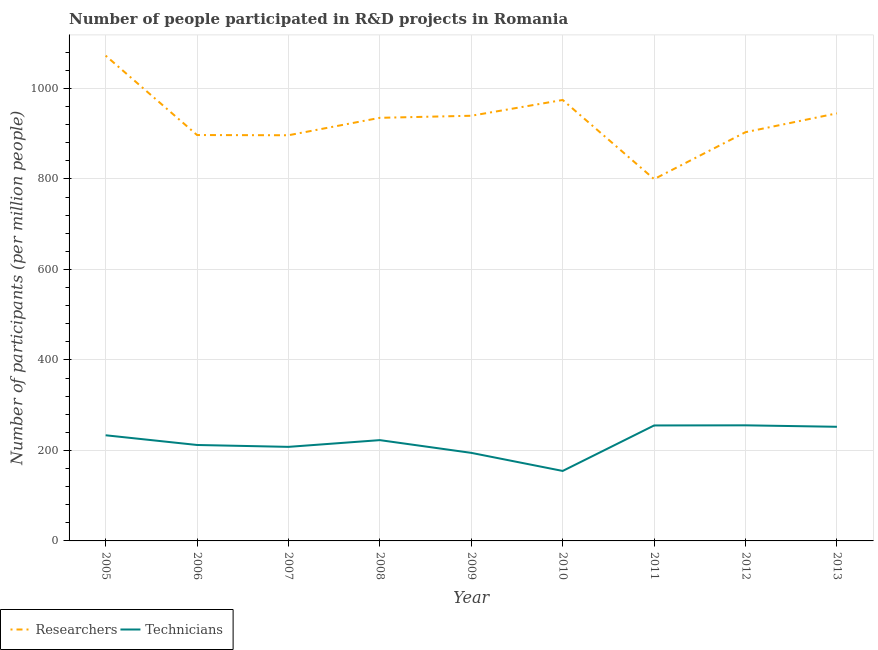How many different coloured lines are there?
Your answer should be very brief. 2. What is the number of technicians in 2008?
Provide a succinct answer. 222.74. Across all years, what is the maximum number of technicians?
Ensure brevity in your answer.  255.45. Across all years, what is the minimum number of technicians?
Offer a terse response. 154.64. In which year was the number of researchers maximum?
Give a very brief answer. 2005. What is the total number of researchers in the graph?
Make the answer very short. 8362.66. What is the difference between the number of researchers in 2012 and that in 2013?
Your response must be concise. -41.64. What is the difference between the number of technicians in 2007 and the number of researchers in 2006?
Make the answer very short. -689.1. What is the average number of technicians per year?
Make the answer very short. 220.91. In the year 2012, what is the difference between the number of technicians and number of researchers?
Provide a short and direct response. -647.83. In how many years, is the number of technicians greater than 160?
Ensure brevity in your answer.  8. What is the ratio of the number of researchers in 2006 to that in 2007?
Provide a succinct answer. 1. Is the number of technicians in 2009 less than that in 2010?
Your answer should be compact. No. What is the difference between the highest and the second highest number of technicians?
Provide a short and direct response. 0.28. What is the difference between the highest and the lowest number of technicians?
Offer a very short reply. 100.81. Does the number of researchers monotonically increase over the years?
Give a very brief answer. No. Is the number of technicians strictly greater than the number of researchers over the years?
Provide a short and direct response. No. Is the number of technicians strictly less than the number of researchers over the years?
Make the answer very short. Yes. How many lines are there?
Ensure brevity in your answer.  2. How many years are there in the graph?
Make the answer very short. 9. Does the graph contain any zero values?
Your answer should be very brief. No. Where does the legend appear in the graph?
Your response must be concise. Bottom left. How many legend labels are there?
Offer a very short reply. 2. What is the title of the graph?
Ensure brevity in your answer.  Number of people participated in R&D projects in Romania. What is the label or title of the X-axis?
Make the answer very short. Year. What is the label or title of the Y-axis?
Make the answer very short. Number of participants (per million people). What is the Number of participants (per million people) of Researchers in 2005?
Give a very brief answer. 1072.42. What is the Number of participants (per million people) of Technicians in 2005?
Keep it short and to the point. 233.47. What is the Number of participants (per million people) of Researchers in 2006?
Make the answer very short. 896.96. What is the Number of participants (per million people) of Technicians in 2006?
Provide a succinct answer. 212.02. What is the Number of participants (per million people) of Researchers in 2007?
Give a very brief answer. 896.49. What is the Number of participants (per million people) of Technicians in 2007?
Ensure brevity in your answer.  207.87. What is the Number of participants (per million people) of Researchers in 2008?
Provide a succinct answer. 935.03. What is the Number of participants (per million people) in Technicians in 2008?
Ensure brevity in your answer.  222.74. What is the Number of participants (per million people) of Researchers in 2009?
Your response must be concise. 939.58. What is the Number of participants (per million people) in Technicians in 2009?
Provide a short and direct response. 194.59. What is the Number of participants (per million people) in Researchers in 2010?
Give a very brief answer. 974.44. What is the Number of participants (per million people) in Technicians in 2010?
Provide a short and direct response. 154.64. What is the Number of participants (per million people) of Researchers in 2011?
Ensure brevity in your answer.  799.54. What is the Number of participants (per million people) of Technicians in 2011?
Your answer should be very brief. 255.18. What is the Number of participants (per million people) in Researchers in 2012?
Give a very brief answer. 903.29. What is the Number of participants (per million people) in Technicians in 2012?
Make the answer very short. 255.45. What is the Number of participants (per million people) of Researchers in 2013?
Offer a terse response. 944.93. What is the Number of participants (per million people) in Technicians in 2013?
Offer a terse response. 252.25. Across all years, what is the maximum Number of participants (per million people) of Researchers?
Your answer should be very brief. 1072.42. Across all years, what is the maximum Number of participants (per million people) of Technicians?
Provide a succinct answer. 255.45. Across all years, what is the minimum Number of participants (per million people) of Researchers?
Make the answer very short. 799.54. Across all years, what is the minimum Number of participants (per million people) of Technicians?
Your response must be concise. 154.64. What is the total Number of participants (per million people) in Researchers in the graph?
Provide a short and direct response. 8362.66. What is the total Number of participants (per million people) of Technicians in the graph?
Provide a succinct answer. 1988.19. What is the difference between the Number of participants (per million people) in Researchers in 2005 and that in 2006?
Offer a terse response. 175.46. What is the difference between the Number of participants (per million people) in Technicians in 2005 and that in 2006?
Ensure brevity in your answer.  21.45. What is the difference between the Number of participants (per million people) in Researchers in 2005 and that in 2007?
Make the answer very short. 175.94. What is the difference between the Number of participants (per million people) in Technicians in 2005 and that in 2007?
Offer a very short reply. 25.6. What is the difference between the Number of participants (per million people) in Researchers in 2005 and that in 2008?
Provide a short and direct response. 137.4. What is the difference between the Number of participants (per million people) in Technicians in 2005 and that in 2008?
Your answer should be compact. 10.73. What is the difference between the Number of participants (per million people) of Researchers in 2005 and that in 2009?
Give a very brief answer. 132.84. What is the difference between the Number of participants (per million people) of Technicians in 2005 and that in 2009?
Your answer should be compact. 38.88. What is the difference between the Number of participants (per million people) of Researchers in 2005 and that in 2010?
Offer a very short reply. 97.98. What is the difference between the Number of participants (per million people) of Technicians in 2005 and that in 2010?
Your response must be concise. 78.83. What is the difference between the Number of participants (per million people) in Researchers in 2005 and that in 2011?
Keep it short and to the point. 272.89. What is the difference between the Number of participants (per million people) of Technicians in 2005 and that in 2011?
Your answer should be compact. -21.71. What is the difference between the Number of participants (per million people) in Researchers in 2005 and that in 2012?
Ensure brevity in your answer.  169.14. What is the difference between the Number of participants (per million people) in Technicians in 2005 and that in 2012?
Your answer should be very brief. -21.98. What is the difference between the Number of participants (per million people) of Researchers in 2005 and that in 2013?
Ensure brevity in your answer.  127.5. What is the difference between the Number of participants (per million people) in Technicians in 2005 and that in 2013?
Make the answer very short. -18.78. What is the difference between the Number of participants (per million people) in Researchers in 2006 and that in 2007?
Give a very brief answer. 0.48. What is the difference between the Number of participants (per million people) of Technicians in 2006 and that in 2007?
Keep it short and to the point. 4.15. What is the difference between the Number of participants (per million people) in Researchers in 2006 and that in 2008?
Provide a short and direct response. -38.06. What is the difference between the Number of participants (per million people) of Technicians in 2006 and that in 2008?
Ensure brevity in your answer.  -10.72. What is the difference between the Number of participants (per million people) of Researchers in 2006 and that in 2009?
Give a very brief answer. -42.61. What is the difference between the Number of participants (per million people) of Technicians in 2006 and that in 2009?
Provide a succinct answer. 17.43. What is the difference between the Number of participants (per million people) of Researchers in 2006 and that in 2010?
Provide a short and direct response. -77.48. What is the difference between the Number of participants (per million people) of Technicians in 2006 and that in 2010?
Your answer should be compact. 57.38. What is the difference between the Number of participants (per million people) in Researchers in 2006 and that in 2011?
Your answer should be compact. 97.43. What is the difference between the Number of participants (per million people) in Technicians in 2006 and that in 2011?
Your answer should be compact. -43.16. What is the difference between the Number of participants (per million people) in Researchers in 2006 and that in 2012?
Provide a succinct answer. -6.32. What is the difference between the Number of participants (per million people) of Technicians in 2006 and that in 2012?
Keep it short and to the point. -43.44. What is the difference between the Number of participants (per million people) of Researchers in 2006 and that in 2013?
Ensure brevity in your answer.  -47.96. What is the difference between the Number of participants (per million people) of Technicians in 2006 and that in 2013?
Ensure brevity in your answer.  -40.23. What is the difference between the Number of participants (per million people) of Researchers in 2007 and that in 2008?
Provide a succinct answer. -38.54. What is the difference between the Number of participants (per million people) of Technicians in 2007 and that in 2008?
Offer a very short reply. -14.87. What is the difference between the Number of participants (per million people) in Researchers in 2007 and that in 2009?
Offer a very short reply. -43.09. What is the difference between the Number of participants (per million people) in Technicians in 2007 and that in 2009?
Your response must be concise. 13.28. What is the difference between the Number of participants (per million people) in Researchers in 2007 and that in 2010?
Your response must be concise. -77.95. What is the difference between the Number of participants (per million people) of Technicians in 2007 and that in 2010?
Ensure brevity in your answer.  53.23. What is the difference between the Number of participants (per million people) of Researchers in 2007 and that in 2011?
Make the answer very short. 96.95. What is the difference between the Number of participants (per million people) in Technicians in 2007 and that in 2011?
Give a very brief answer. -47.31. What is the difference between the Number of participants (per million people) of Researchers in 2007 and that in 2012?
Your answer should be compact. -6.8. What is the difference between the Number of participants (per million people) in Technicians in 2007 and that in 2012?
Your answer should be compact. -47.59. What is the difference between the Number of participants (per million people) of Researchers in 2007 and that in 2013?
Offer a terse response. -48.44. What is the difference between the Number of participants (per million people) in Technicians in 2007 and that in 2013?
Your answer should be very brief. -44.38. What is the difference between the Number of participants (per million people) in Researchers in 2008 and that in 2009?
Keep it short and to the point. -4.55. What is the difference between the Number of participants (per million people) of Technicians in 2008 and that in 2009?
Provide a short and direct response. 28.15. What is the difference between the Number of participants (per million people) of Researchers in 2008 and that in 2010?
Ensure brevity in your answer.  -39.41. What is the difference between the Number of participants (per million people) in Technicians in 2008 and that in 2010?
Make the answer very short. 68.1. What is the difference between the Number of participants (per million people) of Researchers in 2008 and that in 2011?
Make the answer very short. 135.49. What is the difference between the Number of participants (per million people) of Technicians in 2008 and that in 2011?
Ensure brevity in your answer.  -32.44. What is the difference between the Number of participants (per million people) of Researchers in 2008 and that in 2012?
Your response must be concise. 31.74. What is the difference between the Number of participants (per million people) of Technicians in 2008 and that in 2012?
Your answer should be compact. -32.71. What is the difference between the Number of participants (per million people) of Researchers in 2008 and that in 2013?
Keep it short and to the point. -9.9. What is the difference between the Number of participants (per million people) in Technicians in 2008 and that in 2013?
Your response must be concise. -29.51. What is the difference between the Number of participants (per million people) of Researchers in 2009 and that in 2010?
Provide a short and direct response. -34.86. What is the difference between the Number of participants (per million people) in Technicians in 2009 and that in 2010?
Provide a short and direct response. 39.95. What is the difference between the Number of participants (per million people) in Researchers in 2009 and that in 2011?
Your answer should be compact. 140.04. What is the difference between the Number of participants (per million people) in Technicians in 2009 and that in 2011?
Offer a terse response. -60.59. What is the difference between the Number of participants (per million people) of Researchers in 2009 and that in 2012?
Your answer should be very brief. 36.29. What is the difference between the Number of participants (per million people) of Technicians in 2009 and that in 2012?
Make the answer very short. -60.87. What is the difference between the Number of participants (per million people) in Researchers in 2009 and that in 2013?
Your answer should be compact. -5.35. What is the difference between the Number of participants (per million people) in Technicians in 2009 and that in 2013?
Your answer should be very brief. -57.66. What is the difference between the Number of participants (per million people) of Researchers in 2010 and that in 2011?
Your response must be concise. 174.9. What is the difference between the Number of participants (per million people) in Technicians in 2010 and that in 2011?
Give a very brief answer. -100.54. What is the difference between the Number of participants (per million people) in Researchers in 2010 and that in 2012?
Provide a succinct answer. 71.15. What is the difference between the Number of participants (per million people) of Technicians in 2010 and that in 2012?
Give a very brief answer. -100.81. What is the difference between the Number of participants (per million people) of Researchers in 2010 and that in 2013?
Offer a very short reply. 29.52. What is the difference between the Number of participants (per million people) in Technicians in 2010 and that in 2013?
Offer a very short reply. -97.61. What is the difference between the Number of participants (per million people) in Researchers in 2011 and that in 2012?
Your answer should be compact. -103.75. What is the difference between the Number of participants (per million people) of Technicians in 2011 and that in 2012?
Keep it short and to the point. -0.28. What is the difference between the Number of participants (per million people) in Researchers in 2011 and that in 2013?
Keep it short and to the point. -145.39. What is the difference between the Number of participants (per million people) of Technicians in 2011 and that in 2013?
Keep it short and to the point. 2.93. What is the difference between the Number of participants (per million people) of Researchers in 2012 and that in 2013?
Offer a very short reply. -41.64. What is the difference between the Number of participants (per million people) of Technicians in 2012 and that in 2013?
Provide a succinct answer. 3.21. What is the difference between the Number of participants (per million people) of Researchers in 2005 and the Number of participants (per million people) of Technicians in 2006?
Provide a short and direct response. 860.41. What is the difference between the Number of participants (per million people) in Researchers in 2005 and the Number of participants (per million people) in Technicians in 2007?
Your answer should be compact. 864.55. What is the difference between the Number of participants (per million people) of Researchers in 2005 and the Number of participants (per million people) of Technicians in 2008?
Give a very brief answer. 849.68. What is the difference between the Number of participants (per million people) of Researchers in 2005 and the Number of participants (per million people) of Technicians in 2009?
Offer a very short reply. 877.84. What is the difference between the Number of participants (per million people) of Researchers in 2005 and the Number of participants (per million people) of Technicians in 2010?
Ensure brevity in your answer.  917.78. What is the difference between the Number of participants (per million people) of Researchers in 2005 and the Number of participants (per million people) of Technicians in 2011?
Give a very brief answer. 817.25. What is the difference between the Number of participants (per million people) of Researchers in 2005 and the Number of participants (per million people) of Technicians in 2012?
Make the answer very short. 816.97. What is the difference between the Number of participants (per million people) of Researchers in 2005 and the Number of participants (per million people) of Technicians in 2013?
Provide a succinct answer. 820.18. What is the difference between the Number of participants (per million people) of Researchers in 2006 and the Number of participants (per million people) of Technicians in 2007?
Make the answer very short. 689.1. What is the difference between the Number of participants (per million people) in Researchers in 2006 and the Number of participants (per million people) in Technicians in 2008?
Your answer should be compact. 674.22. What is the difference between the Number of participants (per million people) in Researchers in 2006 and the Number of participants (per million people) in Technicians in 2009?
Offer a terse response. 702.38. What is the difference between the Number of participants (per million people) of Researchers in 2006 and the Number of participants (per million people) of Technicians in 2010?
Provide a succinct answer. 742.32. What is the difference between the Number of participants (per million people) in Researchers in 2006 and the Number of participants (per million people) in Technicians in 2011?
Keep it short and to the point. 641.79. What is the difference between the Number of participants (per million people) in Researchers in 2006 and the Number of participants (per million people) in Technicians in 2012?
Your answer should be compact. 641.51. What is the difference between the Number of participants (per million people) of Researchers in 2006 and the Number of participants (per million people) of Technicians in 2013?
Your answer should be compact. 644.72. What is the difference between the Number of participants (per million people) of Researchers in 2007 and the Number of participants (per million people) of Technicians in 2008?
Your response must be concise. 673.75. What is the difference between the Number of participants (per million people) of Researchers in 2007 and the Number of participants (per million people) of Technicians in 2009?
Your answer should be very brief. 701.9. What is the difference between the Number of participants (per million people) in Researchers in 2007 and the Number of participants (per million people) in Technicians in 2010?
Keep it short and to the point. 741.85. What is the difference between the Number of participants (per million people) of Researchers in 2007 and the Number of participants (per million people) of Technicians in 2011?
Provide a short and direct response. 641.31. What is the difference between the Number of participants (per million people) in Researchers in 2007 and the Number of participants (per million people) in Technicians in 2012?
Ensure brevity in your answer.  641.03. What is the difference between the Number of participants (per million people) of Researchers in 2007 and the Number of participants (per million people) of Technicians in 2013?
Keep it short and to the point. 644.24. What is the difference between the Number of participants (per million people) of Researchers in 2008 and the Number of participants (per million people) of Technicians in 2009?
Your response must be concise. 740.44. What is the difference between the Number of participants (per million people) of Researchers in 2008 and the Number of participants (per million people) of Technicians in 2010?
Make the answer very short. 780.39. What is the difference between the Number of participants (per million people) in Researchers in 2008 and the Number of participants (per million people) in Technicians in 2011?
Your answer should be very brief. 679.85. What is the difference between the Number of participants (per million people) of Researchers in 2008 and the Number of participants (per million people) of Technicians in 2012?
Your response must be concise. 679.57. What is the difference between the Number of participants (per million people) of Researchers in 2008 and the Number of participants (per million people) of Technicians in 2013?
Offer a terse response. 682.78. What is the difference between the Number of participants (per million people) in Researchers in 2009 and the Number of participants (per million people) in Technicians in 2010?
Provide a short and direct response. 784.94. What is the difference between the Number of participants (per million people) in Researchers in 2009 and the Number of participants (per million people) in Technicians in 2011?
Keep it short and to the point. 684.4. What is the difference between the Number of participants (per million people) in Researchers in 2009 and the Number of participants (per million people) in Technicians in 2012?
Your answer should be very brief. 684.13. What is the difference between the Number of participants (per million people) of Researchers in 2009 and the Number of participants (per million people) of Technicians in 2013?
Give a very brief answer. 687.33. What is the difference between the Number of participants (per million people) of Researchers in 2010 and the Number of participants (per million people) of Technicians in 2011?
Offer a terse response. 719.26. What is the difference between the Number of participants (per million people) in Researchers in 2010 and the Number of participants (per million people) in Technicians in 2012?
Offer a very short reply. 718.99. What is the difference between the Number of participants (per million people) of Researchers in 2010 and the Number of participants (per million people) of Technicians in 2013?
Your answer should be compact. 722.19. What is the difference between the Number of participants (per million people) of Researchers in 2011 and the Number of participants (per million people) of Technicians in 2012?
Keep it short and to the point. 544.08. What is the difference between the Number of participants (per million people) of Researchers in 2011 and the Number of participants (per million people) of Technicians in 2013?
Your response must be concise. 547.29. What is the difference between the Number of participants (per million people) of Researchers in 2012 and the Number of participants (per million people) of Technicians in 2013?
Offer a very short reply. 651.04. What is the average Number of participants (per million people) in Researchers per year?
Offer a very short reply. 929.18. What is the average Number of participants (per million people) of Technicians per year?
Offer a terse response. 220.91. In the year 2005, what is the difference between the Number of participants (per million people) of Researchers and Number of participants (per million people) of Technicians?
Your answer should be compact. 838.95. In the year 2006, what is the difference between the Number of participants (per million people) of Researchers and Number of participants (per million people) of Technicians?
Provide a succinct answer. 684.95. In the year 2007, what is the difference between the Number of participants (per million people) in Researchers and Number of participants (per million people) in Technicians?
Provide a succinct answer. 688.62. In the year 2008, what is the difference between the Number of participants (per million people) of Researchers and Number of participants (per million people) of Technicians?
Provide a short and direct response. 712.29. In the year 2009, what is the difference between the Number of participants (per million people) of Researchers and Number of participants (per million people) of Technicians?
Offer a very short reply. 744.99. In the year 2010, what is the difference between the Number of participants (per million people) of Researchers and Number of participants (per million people) of Technicians?
Your response must be concise. 819.8. In the year 2011, what is the difference between the Number of participants (per million people) in Researchers and Number of participants (per million people) in Technicians?
Provide a succinct answer. 544.36. In the year 2012, what is the difference between the Number of participants (per million people) of Researchers and Number of participants (per million people) of Technicians?
Your response must be concise. 647.83. In the year 2013, what is the difference between the Number of participants (per million people) in Researchers and Number of participants (per million people) in Technicians?
Make the answer very short. 692.68. What is the ratio of the Number of participants (per million people) in Researchers in 2005 to that in 2006?
Your response must be concise. 1.2. What is the ratio of the Number of participants (per million people) in Technicians in 2005 to that in 2006?
Provide a short and direct response. 1.1. What is the ratio of the Number of participants (per million people) in Researchers in 2005 to that in 2007?
Make the answer very short. 1.2. What is the ratio of the Number of participants (per million people) in Technicians in 2005 to that in 2007?
Give a very brief answer. 1.12. What is the ratio of the Number of participants (per million people) of Researchers in 2005 to that in 2008?
Your answer should be very brief. 1.15. What is the ratio of the Number of participants (per million people) in Technicians in 2005 to that in 2008?
Give a very brief answer. 1.05. What is the ratio of the Number of participants (per million people) in Researchers in 2005 to that in 2009?
Offer a terse response. 1.14. What is the ratio of the Number of participants (per million people) of Technicians in 2005 to that in 2009?
Your answer should be very brief. 1.2. What is the ratio of the Number of participants (per million people) of Researchers in 2005 to that in 2010?
Offer a very short reply. 1.1. What is the ratio of the Number of participants (per million people) in Technicians in 2005 to that in 2010?
Your answer should be compact. 1.51. What is the ratio of the Number of participants (per million people) in Researchers in 2005 to that in 2011?
Keep it short and to the point. 1.34. What is the ratio of the Number of participants (per million people) in Technicians in 2005 to that in 2011?
Provide a succinct answer. 0.91. What is the ratio of the Number of participants (per million people) of Researchers in 2005 to that in 2012?
Offer a very short reply. 1.19. What is the ratio of the Number of participants (per million people) in Technicians in 2005 to that in 2012?
Offer a terse response. 0.91. What is the ratio of the Number of participants (per million people) in Researchers in 2005 to that in 2013?
Give a very brief answer. 1.13. What is the ratio of the Number of participants (per million people) in Technicians in 2005 to that in 2013?
Give a very brief answer. 0.93. What is the ratio of the Number of participants (per million people) in Researchers in 2006 to that in 2007?
Keep it short and to the point. 1. What is the ratio of the Number of participants (per million people) of Researchers in 2006 to that in 2008?
Keep it short and to the point. 0.96. What is the ratio of the Number of participants (per million people) of Technicians in 2006 to that in 2008?
Your answer should be very brief. 0.95. What is the ratio of the Number of participants (per million people) of Researchers in 2006 to that in 2009?
Offer a very short reply. 0.95. What is the ratio of the Number of participants (per million people) of Technicians in 2006 to that in 2009?
Your response must be concise. 1.09. What is the ratio of the Number of participants (per million people) of Researchers in 2006 to that in 2010?
Your answer should be compact. 0.92. What is the ratio of the Number of participants (per million people) in Technicians in 2006 to that in 2010?
Your response must be concise. 1.37. What is the ratio of the Number of participants (per million people) in Researchers in 2006 to that in 2011?
Offer a terse response. 1.12. What is the ratio of the Number of participants (per million people) in Technicians in 2006 to that in 2011?
Give a very brief answer. 0.83. What is the ratio of the Number of participants (per million people) of Researchers in 2006 to that in 2012?
Offer a very short reply. 0.99. What is the ratio of the Number of participants (per million people) in Technicians in 2006 to that in 2012?
Your answer should be compact. 0.83. What is the ratio of the Number of participants (per million people) of Researchers in 2006 to that in 2013?
Your answer should be compact. 0.95. What is the ratio of the Number of participants (per million people) of Technicians in 2006 to that in 2013?
Offer a very short reply. 0.84. What is the ratio of the Number of participants (per million people) of Researchers in 2007 to that in 2008?
Offer a terse response. 0.96. What is the ratio of the Number of participants (per million people) in Technicians in 2007 to that in 2008?
Your answer should be compact. 0.93. What is the ratio of the Number of participants (per million people) of Researchers in 2007 to that in 2009?
Offer a very short reply. 0.95. What is the ratio of the Number of participants (per million people) in Technicians in 2007 to that in 2009?
Ensure brevity in your answer.  1.07. What is the ratio of the Number of participants (per million people) of Researchers in 2007 to that in 2010?
Keep it short and to the point. 0.92. What is the ratio of the Number of participants (per million people) of Technicians in 2007 to that in 2010?
Your answer should be very brief. 1.34. What is the ratio of the Number of participants (per million people) of Researchers in 2007 to that in 2011?
Give a very brief answer. 1.12. What is the ratio of the Number of participants (per million people) of Technicians in 2007 to that in 2011?
Provide a succinct answer. 0.81. What is the ratio of the Number of participants (per million people) in Technicians in 2007 to that in 2012?
Your response must be concise. 0.81. What is the ratio of the Number of participants (per million people) in Researchers in 2007 to that in 2013?
Give a very brief answer. 0.95. What is the ratio of the Number of participants (per million people) of Technicians in 2007 to that in 2013?
Ensure brevity in your answer.  0.82. What is the ratio of the Number of participants (per million people) of Researchers in 2008 to that in 2009?
Ensure brevity in your answer.  1. What is the ratio of the Number of participants (per million people) of Technicians in 2008 to that in 2009?
Give a very brief answer. 1.14. What is the ratio of the Number of participants (per million people) of Researchers in 2008 to that in 2010?
Your answer should be compact. 0.96. What is the ratio of the Number of participants (per million people) of Technicians in 2008 to that in 2010?
Offer a very short reply. 1.44. What is the ratio of the Number of participants (per million people) in Researchers in 2008 to that in 2011?
Your answer should be compact. 1.17. What is the ratio of the Number of participants (per million people) in Technicians in 2008 to that in 2011?
Offer a very short reply. 0.87. What is the ratio of the Number of participants (per million people) of Researchers in 2008 to that in 2012?
Make the answer very short. 1.04. What is the ratio of the Number of participants (per million people) of Technicians in 2008 to that in 2012?
Your answer should be very brief. 0.87. What is the ratio of the Number of participants (per million people) of Technicians in 2008 to that in 2013?
Keep it short and to the point. 0.88. What is the ratio of the Number of participants (per million people) of Researchers in 2009 to that in 2010?
Ensure brevity in your answer.  0.96. What is the ratio of the Number of participants (per million people) of Technicians in 2009 to that in 2010?
Your answer should be compact. 1.26. What is the ratio of the Number of participants (per million people) in Researchers in 2009 to that in 2011?
Provide a short and direct response. 1.18. What is the ratio of the Number of participants (per million people) of Technicians in 2009 to that in 2011?
Offer a terse response. 0.76. What is the ratio of the Number of participants (per million people) in Researchers in 2009 to that in 2012?
Provide a short and direct response. 1.04. What is the ratio of the Number of participants (per million people) in Technicians in 2009 to that in 2012?
Ensure brevity in your answer.  0.76. What is the ratio of the Number of participants (per million people) in Researchers in 2009 to that in 2013?
Provide a short and direct response. 0.99. What is the ratio of the Number of participants (per million people) of Technicians in 2009 to that in 2013?
Offer a very short reply. 0.77. What is the ratio of the Number of participants (per million people) of Researchers in 2010 to that in 2011?
Your answer should be very brief. 1.22. What is the ratio of the Number of participants (per million people) of Technicians in 2010 to that in 2011?
Your answer should be compact. 0.61. What is the ratio of the Number of participants (per million people) in Researchers in 2010 to that in 2012?
Offer a terse response. 1.08. What is the ratio of the Number of participants (per million people) in Technicians in 2010 to that in 2012?
Provide a succinct answer. 0.61. What is the ratio of the Number of participants (per million people) in Researchers in 2010 to that in 2013?
Give a very brief answer. 1.03. What is the ratio of the Number of participants (per million people) of Technicians in 2010 to that in 2013?
Provide a succinct answer. 0.61. What is the ratio of the Number of participants (per million people) in Researchers in 2011 to that in 2012?
Ensure brevity in your answer.  0.89. What is the ratio of the Number of participants (per million people) in Technicians in 2011 to that in 2012?
Your answer should be compact. 1. What is the ratio of the Number of participants (per million people) of Researchers in 2011 to that in 2013?
Ensure brevity in your answer.  0.85. What is the ratio of the Number of participants (per million people) in Technicians in 2011 to that in 2013?
Give a very brief answer. 1.01. What is the ratio of the Number of participants (per million people) in Researchers in 2012 to that in 2013?
Offer a terse response. 0.96. What is the ratio of the Number of participants (per million people) in Technicians in 2012 to that in 2013?
Provide a succinct answer. 1.01. What is the difference between the highest and the second highest Number of participants (per million people) in Researchers?
Your answer should be compact. 97.98. What is the difference between the highest and the second highest Number of participants (per million people) of Technicians?
Offer a very short reply. 0.28. What is the difference between the highest and the lowest Number of participants (per million people) in Researchers?
Make the answer very short. 272.89. What is the difference between the highest and the lowest Number of participants (per million people) in Technicians?
Provide a short and direct response. 100.81. 